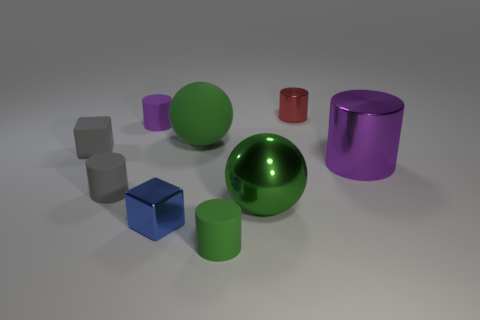How many other small rubber things have the same shape as the small green object?
Your answer should be compact. 2. There is a cube in front of the small gray matte cube; does it have the same color as the cylinder in front of the tiny gray rubber cylinder?
Provide a succinct answer. No. What number of objects are either cylinders or matte balls?
Offer a terse response. 6. How many tiny objects have the same material as the small green cylinder?
Offer a terse response. 3. Are there fewer green cylinders than big metal objects?
Make the answer very short. Yes. Is the material of the big thing in front of the large purple metal object the same as the green cylinder?
Give a very brief answer. No. What number of spheres are either red metallic objects or gray rubber things?
Offer a very short reply. 0. What is the shape of the tiny object that is to the left of the green cylinder and in front of the big green shiny sphere?
Offer a very short reply. Cube. What is the color of the tiny block left of the small metal cube in front of the thing that is to the left of the gray cylinder?
Make the answer very short. Gray. Is the number of tiny blocks that are behind the big rubber sphere less than the number of purple rubber objects?
Offer a very short reply. Yes. 